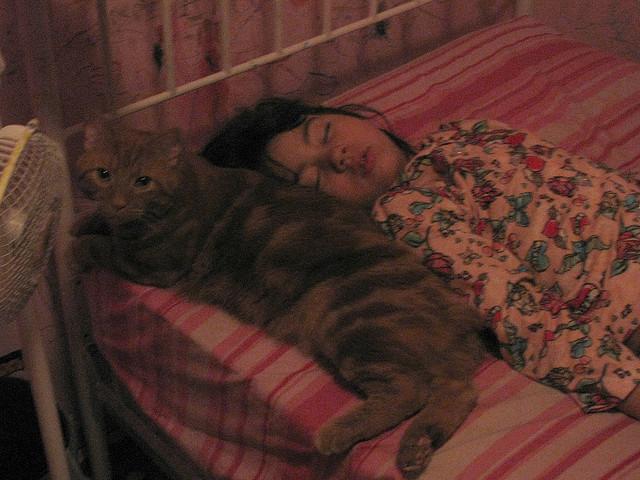Are the lights turned off?
Quick response, please. Yes. What animal is next to the girl?
Short answer required. Cat. Is this cute?
Give a very brief answer. Yes. 